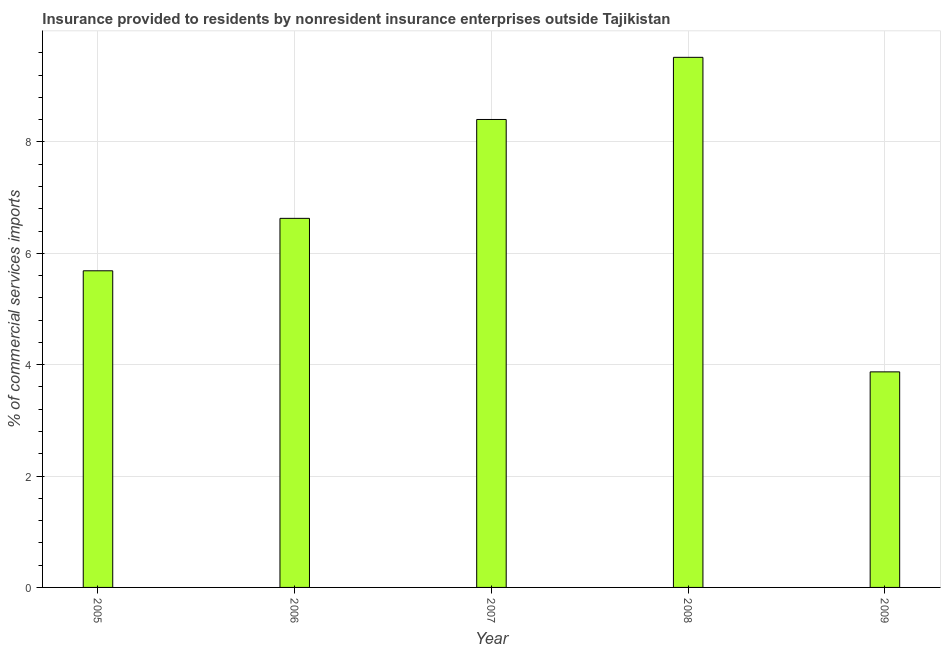Does the graph contain grids?
Keep it short and to the point. Yes. What is the title of the graph?
Offer a terse response. Insurance provided to residents by nonresident insurance enterprises outside Tajikistan. What is the label or title of the X-axis?
Ensure brevity in your answer.  Year. What is the label or title of the Y-axis?
Make the answer very short. % of commercial services imports. What is the insurance provided by non-residents in 2009?
Keep it short and to the point. 3.87. Across all years, what is the maximum insurance provided by non-residents?
Your answer should be very brief. 9.52. Across all years, what is the minimum insurance provided by non-residents?
Offer a terse response. 3.87. In which year was the insurance provided by non-residents minimum?
Make the answer very short. 2009. What is the sum of the insurance provided by non-residents?
Your answer should be compact. 34.11. What is the difference between the insurance provided by non-residents in 2005 and 2009?
Your answer should be compact. 1.81. What is the average insurance provided by non-residents per year?
Make the answer very short. 6.82. What is the median insurance provided by non-residents?
Give a very brief answer. 6.63. In how many years, is the insurance provided by non-residents greater than 7.6 %?
Offer a very short reply. 2. What is the ratio of the insurance provided by non-residents in 2005 to that in 2009?
Give a very brief answer. 1.47. Is the insurance provided by non-residents in 2005 less than that in 2007?
Keep it short and to the point. Yes. What is the difference between the highest and the second highest insurance provided by non-residents?
Make the answer very short. 1.12. What is the difference between the highest and the lowest insurance provided by non-residents?
Ensure brevity in your answer.  5.65. In how many years, is the insurance provided by non-residents greater than the average insurance provided by non-residents taken over all years?
Provide a succinct answer. 2. What is the % of commercial services imports of 2005?
Provide a succinct answer. 5.69. What is the % of commercial services imports of 2006?
Provide a succinct answer. 6.63. What is the % of commercial services imports in 2007?
Give a very brief answer. 8.4. What is the % of commercial services imports of 2008?
Provide a succinct answer. 9.52. What is the % of commercial services imports in 2009?
Ensure brevity in your answer.  3.87. What is the difference between the % of commercial services imports in 2005 and 2006?
Offer a very short reply. -0.94. What is the difference between the % of commercial services imports in 2005 and 2007?
Your answer should be very brief. -2.72. What is the difference between the % of commercial services imports in 2005 and 2008?
Your answer should be compact. -3.83. What is the difference between the % of commercial services imports in 2005 and 2009?
Make the answer very short. 1.82. What is the difference between the % of commercial services imports in 2006 and 2007?
Your answer should be very brief. -1.78. What is the difference between the % of commercial services imports in 2006 and 2008?
Provide a short and direct response. -2.89. What is the difference between the % of commercial services imports in 2006 and 2009?
Provide a short and direct response. 2.76. What is the difference between the % of commercial services imports in 2007 and 2008?
Give a very brief answer. -1.12. What is the difference between the % of commercial services imports in 2007 and 2009?
Your answer should be compact. 4.53. What is the difference between the % of commercial services imports in 2008 and 2009?
Provide a succinct answer. 5.65. What is the ratio of the % of commercial services imports in 2005 to that in 2006?
Keep it short and to the point. 0.86. What is the ratio of the % of commercial services imports in 2005 to that in 2007?
Give a very brief answer. 0.68. What is the ratio of the % of commercial services imports in 2005 to that in 2008?
Offer a very short reply. 0.6. What is the ratio of the % of commercial services imports in 2005 to that in 2009?
Keep it short and to the point. 1.47. What is the ratio of the % of commercial services imports in 2006 to that in 2007?
Keep it short and to the point. 0.79. What is the ratio of the % of commercial services imports in 2006 to that in 2008?
Your answer should be compact. 0.7. What is the ratio of the % of commercial services imports in 2006 to that in 2009?
Offer a very short reply. 1.71. What is the ratio of the % of commercial services imports in 2007 to that in 2008?
Offer a very short reply. 0.88. What is the ratio of the % of commercial services imports in 2007 to that in 2009?
Your answer should be compact. 2.17. What is the ratio of the % of commercial services imports in 2008 to that in 2009?
Your response must be concise. 2.46. 